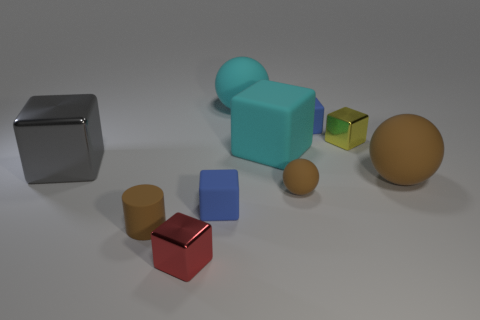Subtract all red cubes. How many cubes are left? 5 Subtract all blue blocks. How many blocks are left? 4 Subtract 2 blocks. How many blocks are left? 4 Subtract all gray cubes. Subtract all blue spheres. How many cubes are left? 5 Subtract all cubes. How many objects are left? 4 Subtract 0 green cylinders. How many objects are left? 10 Subtract all large blue rubber cylinders. Subtract all brown cylinders. How many objects are left? 9 Add 9 tiny red things. How many tiny red things are left? 10 Add 6 large cyan objects. How many large cyan objects exist? 8 